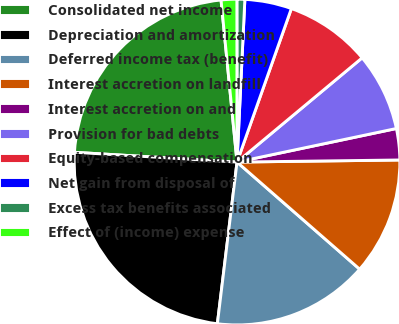Convert chart. <chart><loc_0><loc_0><loc_500><loc_500><pie_chart><fcel>Consolidated net income<fcel>Depreciation and amortization<fcel>Deferred income tax (benefit)<fcel>Interest accretion on landfill<fcel>Interest accretion on and<fcel>Provision for bad debts<fcel>Equity-based compensation<fcel>Net gain from disposal of<fcel>Excess tax benefits associated<fcel>Effect of (income) expense<nl><fcel>22.48%<fcel>24.03%<fcel>15.5%<fcel>11.63%<fcel>3.1%<fcel>7.75%<fcel>8.53%<fcel>4.65%<fcel>0.78%<fcel>1.55%<nl></chart> 